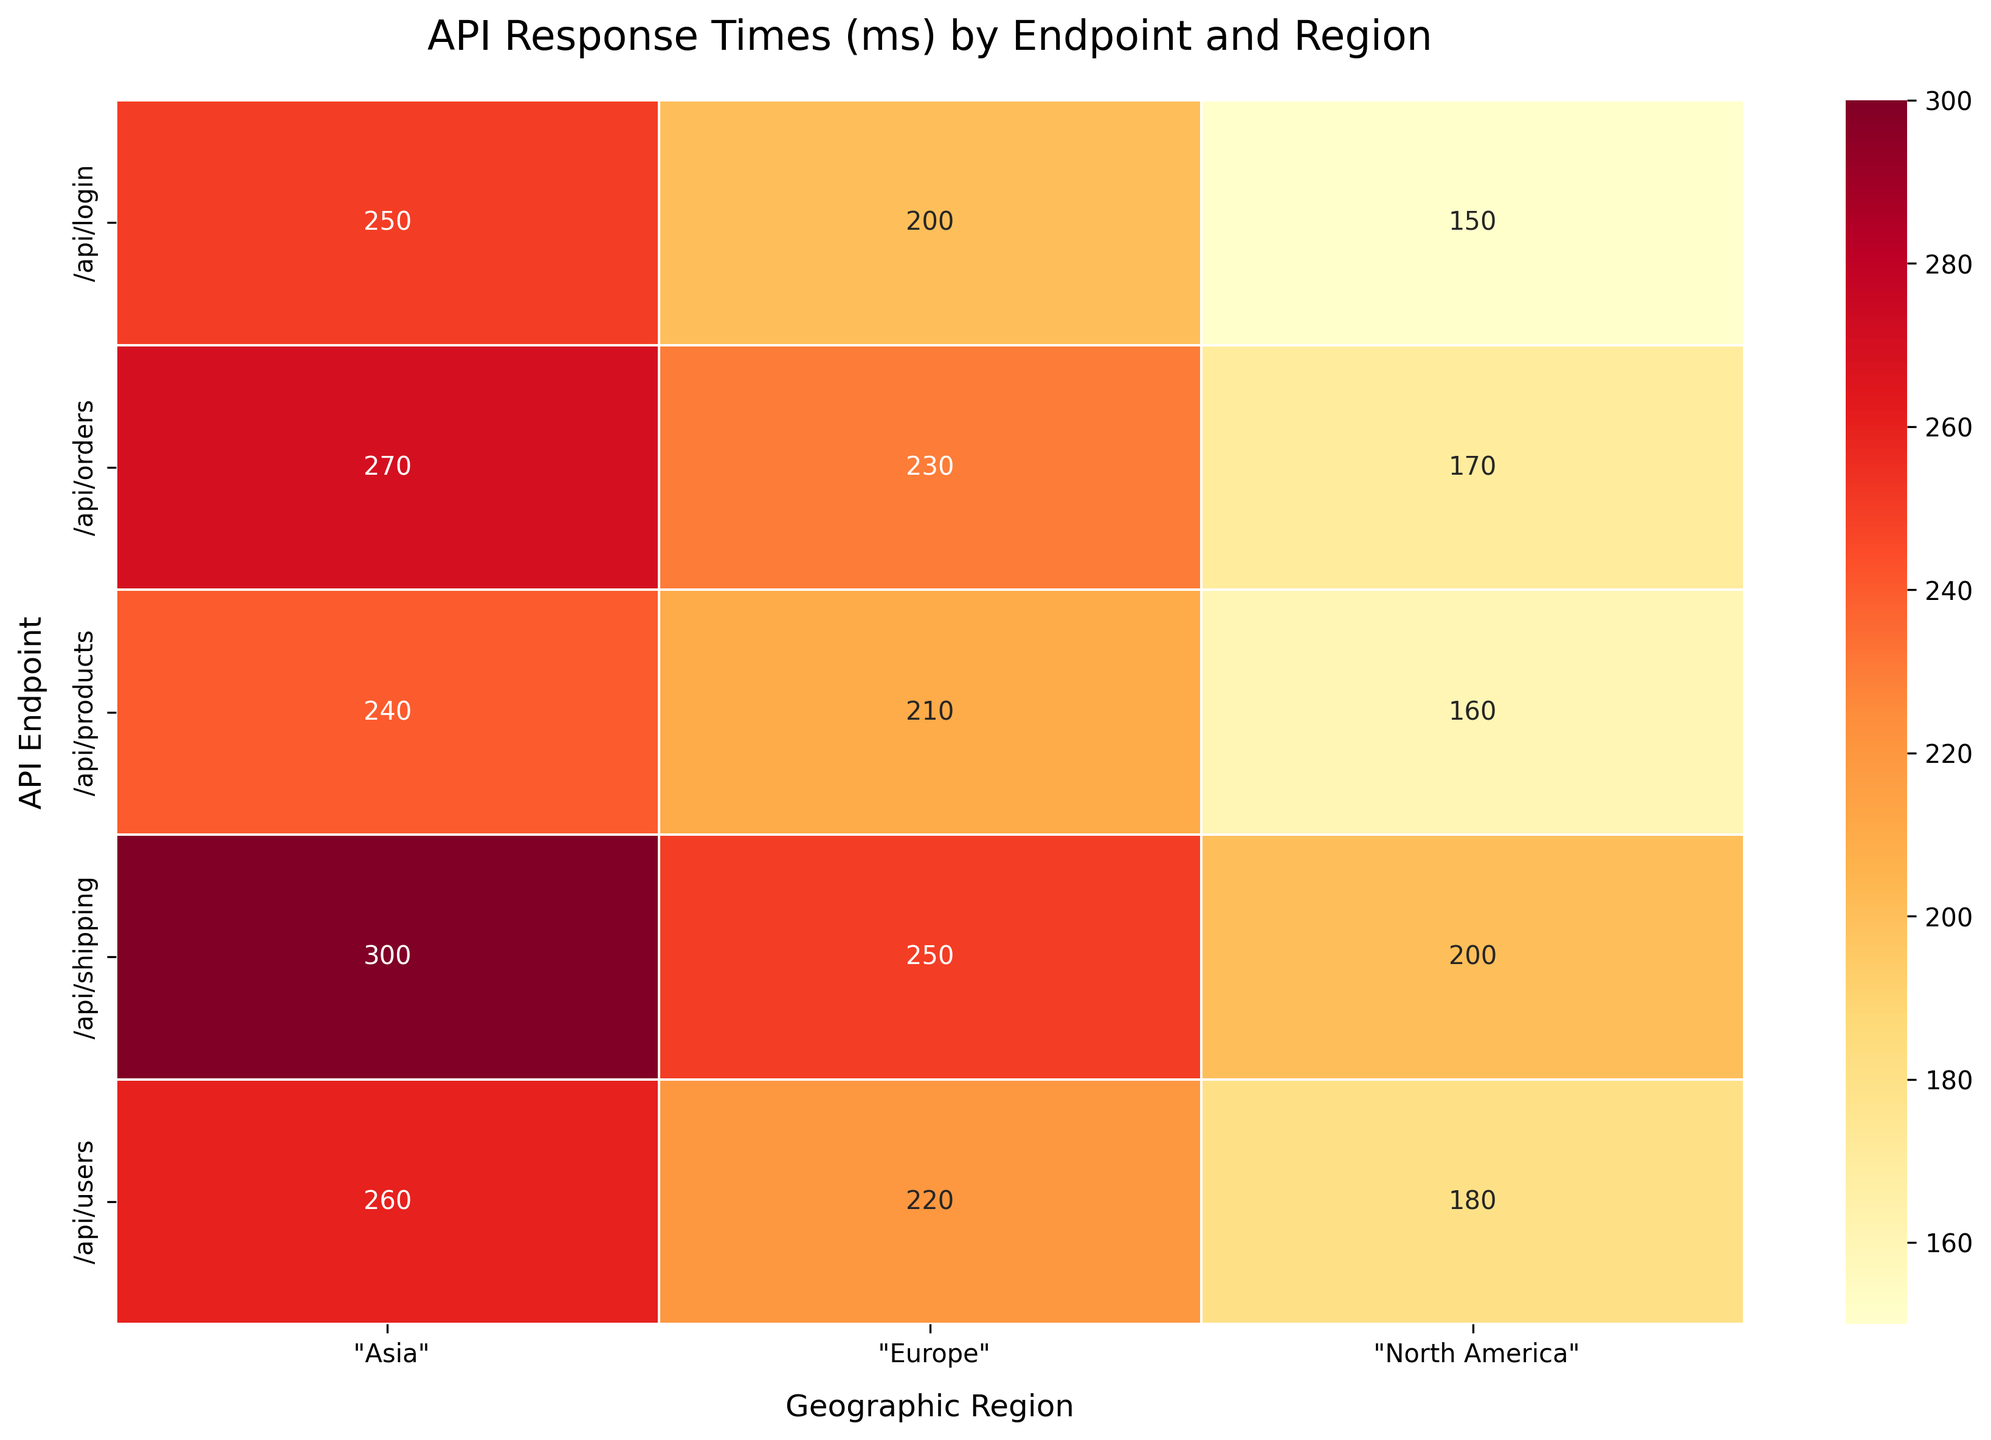What is the title of the heatmap? The title of the heatmap is typically located at the top center of the figure. In this case, it should be 'API Response Times (ms) by Endpoint and Region'.
Answer: API Response Times (ms) by Endpoint and Region Which API endpoint has the highest average response time in Asia? To find the highest average response time in Asia, look for the endpoint in the 'Asia' column with the largest value. The "/api/shipping" endpoint has a response time of 300 ms, which is the highest.
Answer: /api/shipping How many geographic regions are compared in the heatmap? The number of geographic regions can be found on the x-axis of the heatmap. Here, the regions are 'North America', 'Europe', and 'Asia', making a total of 3 regions.
Answer: 3 Which region has the overall lowest response times across all endpoints? To determine the region with the lowest response times, compare the sums of the values in each column. North America generally has the lowest individual values across endpoints compared to Europe and Asia.
Answer: North America What is the average response time for the /api/login endpoint across all regions? The average response time can be calculated by summing the individual response times for '/api/login' in each region and dividing by the number of regions. (150 + 200 + 250) / 3 = 200 ms.
Answer: 200 ms Which endpoint has the most varied response times across regions? To determine the most varied response times, calculate the range (maximum value - minimum value) for each endpoint across the regions. '/api/shipping' has the most variation with a range of 300-200=100 ms.
Answer: /api/shipping For the /api/orders endpoint, what is the difference in response time between Europe and North America? Subtract the response time for North America from that of Europe for the '/api/orders' endpoint. 230 ms (Europe) - 170 ms (North America) = 60 ms.
Answer: 60 ms Which endpoint has the lowest average response time in North America? Find the smallest value in the 'North America' column. The '/api/login' endpoint has the lowest response time at 150 ms.
Answer: /api/login 